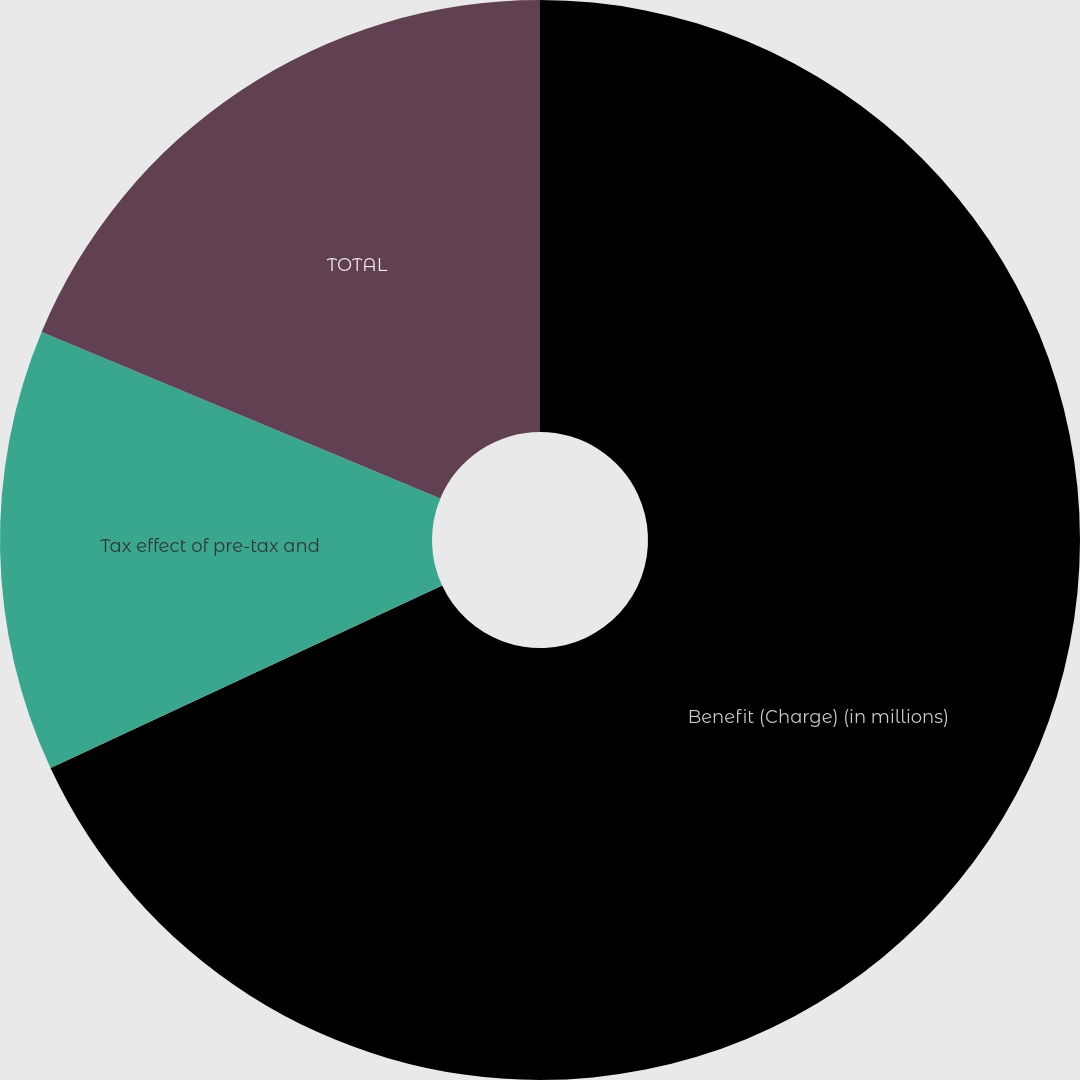Convert chart to OTSL. <chart><loc_0><loc_0><loc_500><loc_500><pie_chart><fcel>Benefit (Charge) (in millions)<fcel>Tax effect of pre-tax and<fcel>TOTAL<nl><fcel>68.06%<fcel>13.23%<fcel>18.71%<nl></chart> 